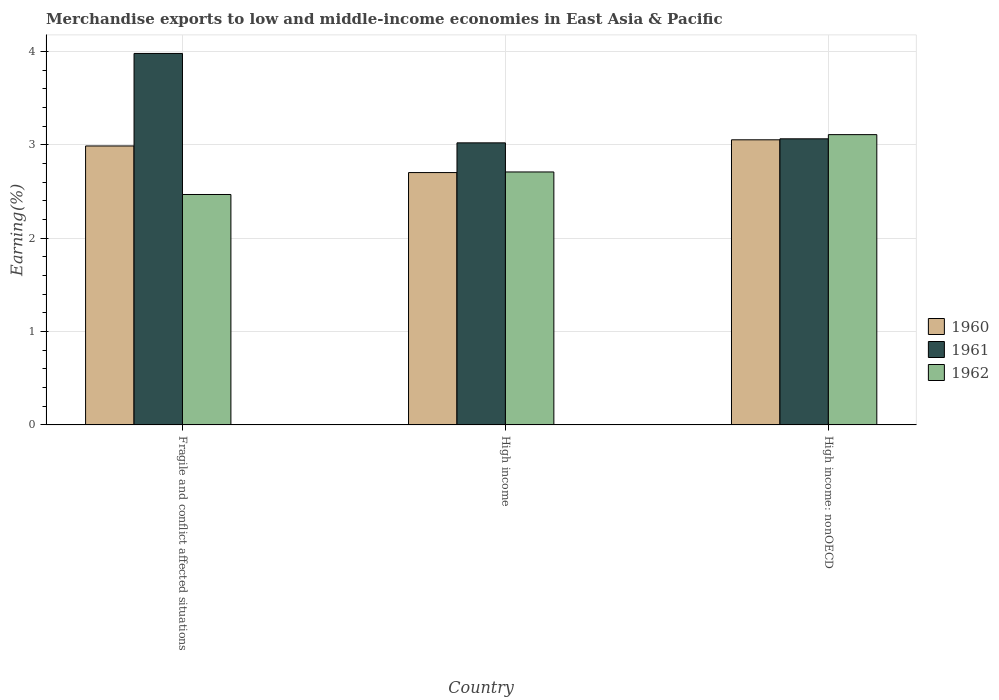How many groups of bars are there?
Your answer should be very brief. 3. Are the number of bars on each tick of the X-axis equal?
Provide a short and direct response. Yes. How many bars are there on the 3rd tick from the right?
Provide a succinct answer. 3. What is the label of the 1st group of bars from the left?
Give a very brief answer. Fragile and conflict affected situations. What is the percentage of amount earned from merchandise exports in 1962 in High income: nonOECD?
Ensure brevity in your answer.  3.11. Across all countries, what is the maximum percentage of amount earned from merchandise exports in 1960?
Keep it short and to the point. 3.05. Across all countries, what is the minimum percentage of amount earned from merchandise exports in 1960?
Your answer should be compact. 2.7. In which country was the percentage of amount earned from merchandise exports in 1960 maximum?
Ensure brevity in your answer.  High income: nonOECD. In which country was the percentage of amount earned from merchandise exports in 1962 minimum?
Your answer should be very brief. Fragile and conflict affected situations. What is the total percentage of amount earned from merchandise exports in 1961 in the graph?
Make the answer very short. 10.06. What is the difference between the percentage of amount earned from merchandise exports in 1961 in Fragile and conflict affected situations and that in High income: nonOECD?
Your response must be concise. 0.91. What is the difference between the percentage of amount earned from merchandise exports in 1960 in High income: nonOECD and the percentage of amount earned from merchandise exports in 1961 in Fragile and conflict affected situations?
Keep it short and to the point. -0.92. What is the average percentage of amount earned from merchandise exports in 1960 per country?
Offer a terse response. 2.91. What is the difference between the percentage of amount earned from merchandise exports of/in 1962 and percentage of amount earned from merchandise exports of/in 1961 in High income: nonOECD?
Keep it short and to the point. 0.04. What is the ratio of the percentage of amount earned from merchandise exports in 1961 in Fragile and conflict affected situations to that in High income: nonOECD?
Offer a terse response. 1.3. Is the difference between the percentage of amount earned from merchandise exports in 1962 in Fragile and conflict affected situations and High income greater than the difference between the percentage of amount earned from merchandise exports in 1961 in Fragile and conflict affected situations and High income?
Offer a very short reply. No. What is the difference between the highest and the second highest percentage of amount earned from merchandise exports in 1961?
Ensure brevity in your answer.  0.04. What is the difference between the highest and the lowest percentage of amount earned from merchandise exports in 1960?
Make the answer very short. 0.35. How many bars are there?
Offer a terse response. 9. What is the difference between two consecutive major ticks on the Y-axis?
Your response must be concise. 1. Are the values on the major ticks of Y-axis written in scientific E-notation?
Your response must be concise. No. Where does the legend appear in the graph?
Keep it short and to the point. Center right. How many legend labels are there?
Ensure brevity in your answer.  3. How are the legend labels stacked?
Make the answer very short. Vertical. What is the title of the graph?
Your response must be concise. Merchandise exports to low and middle-income economies in East Asia & Pacific. What is the label or title of the X-axis?
Provide a short and direct response. Country. What is the label or title of the Y-axis?
Offer a terse response. Earning(%). What is the Earning(%) in 1960 in Fragile and conflict affected situations?
Provide a succinct answer. 2.99. What is the Earning(%) of 1961 in Fragile and conflict affected situations?
Provide a succinct answer. 3.98. What is the Earning(%) in 1962 in Fragile and conflict affected situations?
Offer a terse response. 2.47. What is the Earning(%) of 1960 in High income?
Offer a very short reply. 2.7. What is the Earning(%) of 1961 in High income?
Provide a succinct answer. 3.02. What is the Earning(%) in 1962 in High income?
Keep it short and to the point. 2.71. What is the Earning(%) of 1960 in High income: nonOECD?
Provide a short and direct response. 3.05. What is the Earning(%) of 1961 in High income: nonOECD?
Provide a short and direct response. 3.06. What is the Earning(%) in 1962 in High income: nonOECD?
Ensure brevity in your answer.  3.11. Across all countries, what is the maximum Earning(%) in 1960?
Keep it short and to the point. 3.05. Across all countries, what is the maximum Earning(%) of 1961?
Your answer should be compact. 3.98. Across all countries, what is the maximum Earning(%) of 1962?
Offer a very short reply. 3.11. Across all countries, what is the minimum Earning(%) of 1960?
Offer a terse response. 2.7. Across all countries, what is the minimum Earning(%) of 1961?
Keep it short and to the point. 3.02. Across all countries, what is the minimum Earning(%) of 1962?
Offer a very short reply. 2.47. What is the total Earning(%) in 1960 in the graph?
Ensure brevity in your answer.  8.74. What is the total Earning(%) in 1961 in the graph?
Offer a very short reply. 10.06. What is the total Earning(%) of 1962 in the graph?
Your response must be concise. 8.29. What is the difference between the Earning(%) of 1960 in Fragile and conflict affected situations and that in High income?
Make the answer very short. 0.29. What is the difference between the Earning(%) of 1961 in Fragile and conflict affected situations and that in High income?
Your response must be concise. 0.96. What is the difference between the Earning(%) of 1962 in Fragile and conflict affected situations and that in High income?
Offer a very short reply. -0.24. What is the difference between the Earning(%) of 1960 in Fragile and conflict affected situations and that in High income: nonOECD?
Your response must be concise. -0.07. What is the difference between the Earning(%) in 1961 in Fragile and conflict affected situations and that in High income: nonOECD?
Your answer should be very brief. 0.91. What is the difference between the Earning(%) of 1962 in Fragile and conflict affected situations and that in High income: nonOECD?
Offer a very short reply. -0.64. What is the difference between the Earning(%) in 1960 in High income and that in High income: nonOECD?
Provide a short and direct response. -0.35. What is the difference between the Earning(%) in 1961 in High income and that in High income: nonOECD?
Provide a short and direct response. -0.04. What is the difference between the Earning(%) of 1962 in High income and that in High income: nonOECD?
Your response must be concise. -0.4. What is the difference between the Earning(%) in 1960 in Fragile and conflict affected situations and the Earning(%) in 1961 in High income?
Your response must be concise. -0.03. What is the difference between the Earning(%) in 1960 in Fragile and conflict affected situations and the Earning(%) in 1962 in High income?
Keep it short and to the point. 0.28. What is the difference between the Earning(%) in 1961 in Fragile and conflict affected situations and the Earning(%) in 1962 in High income?
Provide a short and direct response. 1.27. What is the difference between the Earning(%) in 1960 in Fragile and conflict affected situations and the Earning(%) in 1961 in High income: nonOECD?
Your answer should be compact. -0.08. What is the difference between the Earning(%) of 1960 in Fragile and conflict affected situations and the Earning(%) of 1962 in High income: nonOECD?
Offer a terse response. -0.12. What is the difference between the Earning(%) of 1961 in Fragile and conflict affected situations and the Earning(%) of 1962 in High income: nonOECD?
Your response must be concise. 0.87. What is the difference between the Earning(%) in 1960 in High income and the Earning(%) in 1961 in High income: nonOECD?
Provide a succinct answer. -0.36. What is the difference between the Earning(%) of 1960 in High income and the Earning(%) of 1962 in High income: nonOECD?
Make the answer very short. -0.41. What is the difference between the Earning(%) of 1961 in High income and the Earning(%) of 1962 in High income: nonOECD?
Make the answer very short. -0.09. What is the average Earning(%) of 1960 per country?
Provide a succinct answer. 2.91. What is the average Earning(%) in 1961 per country?
Ensure brevity in your answer.  3.35. What is the average Earning(%) of 1962 per country?
Ensure brevity in your answer.  2.76. What is the difference between the Earning(%) in 1960 and Earning(%) in 1961 in Fragile and conflict affected situations?
Make the answer very short. -0.99. What is the difference between the Earning(%) in 1960 and Earning(%) in 1962 in Fragile and conflict affected situations?
Give a very brief answer. 0.52. What is the difference between the Earning(%) of 1961 and Earning(%) of 1962 in Fragile and conflict affected situations?
Offer a terse response. 1.51. What is the difference between the Earning(%) in 1960 and Earning(%) in 1961 in High income?
Give a very brief answer. -0.32. What is the difference between the Earning(%) of 1960 and Earning(%) of 1962 in High income?
Make the answer very short. -0.01. What is the difference between the Earning(%) in 1961 and Earning(%) in 1962 in High income?
Your answer should be compact. 0.31. What is the difference between the Earning(%) of 1960 and Earning(%) of 1961 in High income: nonOECD?
Your answer should be very brief. -0.01. What is the difference between the Earning(%) in 1960 and Earning(%) in 1962 in High income: nonOECD?
Give a very brief answer. -0.06. What is the difference between the Earning(%) of 1961 and Earning(%) of 1962 in High income: nonOECD?
Your response must be concise. -0.04. What is the ratio of the Earning(%) of 1960 in Fragile and conflict affected situations to that in High income?
Provide a succinct answer. 1.11. What is the ratio of the Earning(%) of 1961 in Fragile and conflict affected situations to that in High income?
Provide a succinct answer. 1.32. What is the ratio of the Earning(%) of 1962 in Fragile and conflict affected situations to that in High income?
Provide a succinct answer. 0.91. What is the ratio of the Earning(%) in 1960 in Fragile and conflict affected situations to that in High income: nonOECD?
Make the answer very short. 0.98. What is the ratio of the Earning(%) of 1961 in Fragile and conflict affected situations to that in High income: nonOECD?
Your answer should be compact. 1.3. What is the ratio of the Earning(%) of 1962 in Fragile and conflict affected situations to that in High income: nonOECD?
Offer a very short reply. 0.79. What is the ratio of the Earning(%) of 1960 in High income to that in High income: nonOECD?
Offer a terse response. 0.89. What is the ratio of the Earning(%) of 1961 in High income to that in High income: nonOECD?
Your answer should be very brief. 0.99. What is the ratio of the Earning(%) in 1962 in High income to that in High income: nonOECD?
Your answer should be very brief. 0.87. What is the difference between the highest and the second highest Earning(%) in 1960?
Offer a terse response. 0.07. What is the difference between the highest and the second highest Earning(%) of 1961?
Your answer should be compact. 0.91. What is the difference between the highest and the second highest Earning(%) of 1962?
Give a very brief answer. 0.4. What is the difference between the highest and the lowest Earning(%) of 1960?
Make the answer very short. 0.35. What is the difference between the highest and the lowest Earning(%) in 1961?
Make the answer very short. 0.96. What is the difference between the highest and the lowest Earning(%) in 1962?
Provide a short and direct response. 0.64. 